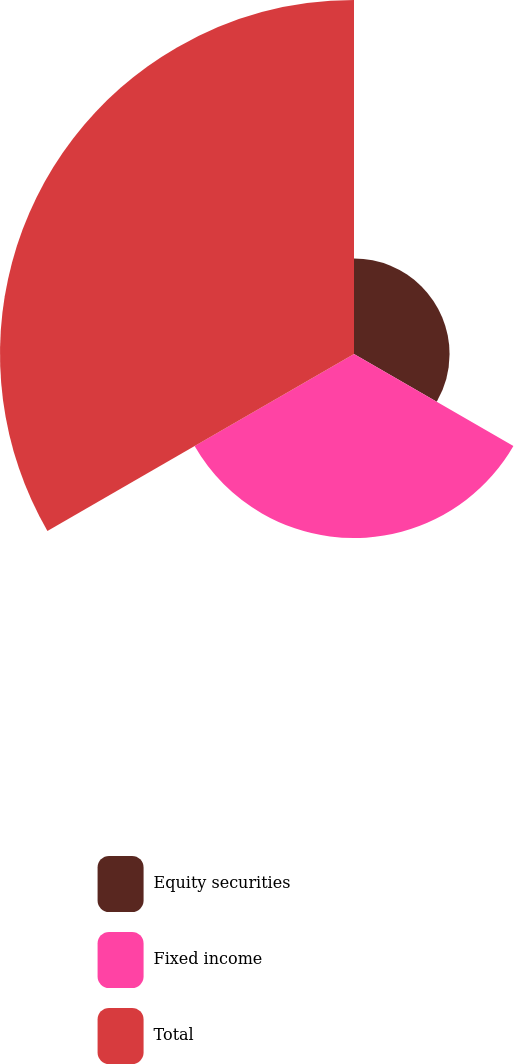<chart> <loc_0><loc_0><loc_500><loc_500><pie_chart><fcel>Equity securities<fcel>Fixed income<fcel>Total<nl><fcel>15.08%<fcel>29.05%<fcel>55.87%<nl></chart> 